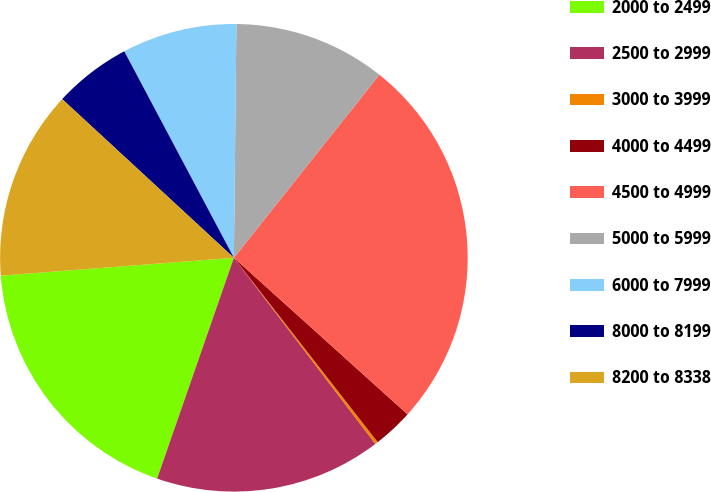Convert chart. <chart><loc_0><loc_0><loc_500><loc_500><pie_chart><fcel>2000 to 2499<fcel>2500 to 2999<fcel>3000 to 3999<fcel>4000 to 4499<fcel>4500 to 4999<fcel>5000 to 5999<fcel>6000 to 7999<fcel>8000 to 8199<fcel>8200 to 8338<nl><fcel>18.46%<fcel>15.67%<fcel>0.2%<fcel>2.78%<fcel>25.99%<fcel>10.52%<fcel>7.94%<fcel>5.36%<fcel>13.09%<nl></chart> 